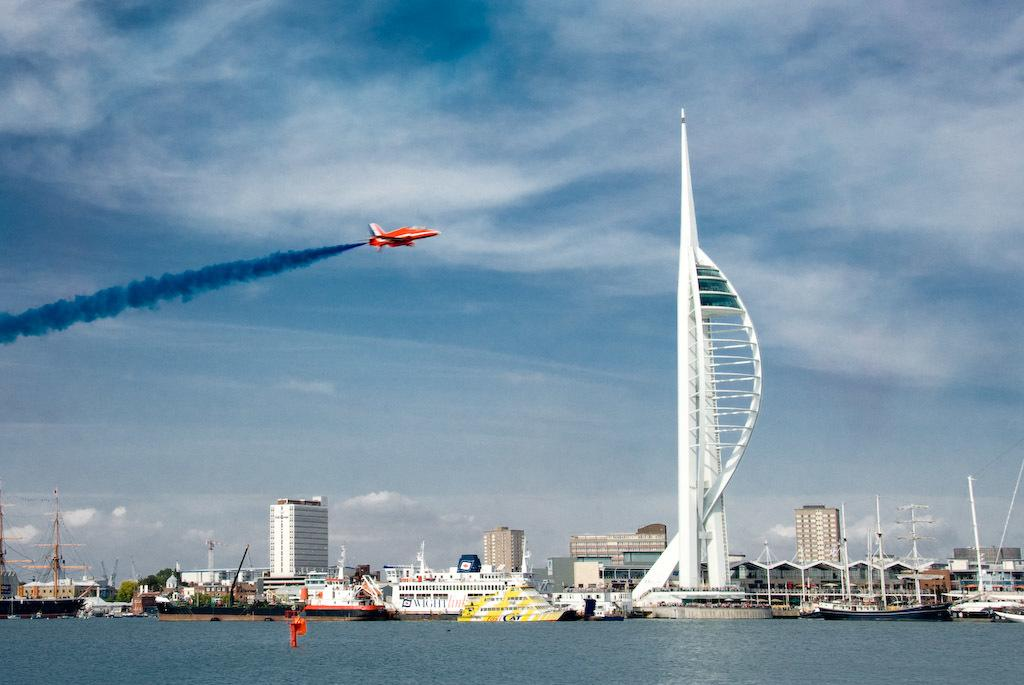What type of structures can be seen in the image? There are buildings in the image. What vehicles are present in the image? There are boats in the image. What is in the water in the image? There is a pole in the water. What type of vegetation is visible in the image? There are trees in the image. What type of infrastructure is present in the image? There are electric poles in the image. What connects the electric poles in the image? There are cables in the image. What type of transportation is depicted in the image? There is a flight in the image. What is present in the air in the image? There is smoke in the air. What is visible in the sky in the image? There are clouds in the sky. What type of vegetable is growing on the flight in the image? There are no vegetables present in the image, and the flight is not a place where vegetables would grow. How does the fear of heights affect the people on the flight in the image? There is no indication of fear or people in the image, so it cannot be determined how fear of heights might affect them. 